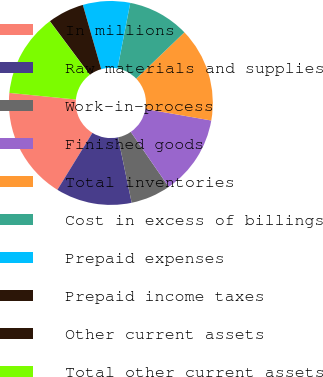<chart> <loc_0><loc_0><loc_500><loc_500><pie_chart><fcel>In millions<fcel>Raw materials and supplies<fcel>Work-in-process<fcel>Finished goods<fcel>Total inventories<fcel>Cost in excess of billings<fcel>Prepaid expenses<fcel>Prepaid income taxes<fcel>Other current assets<fcel>Total other current assets<nl><fcel>17.79%<fcel>12.06%<fcel>6.33%<fcel>12.64%<fcel>14.93%<fcel>9.77%<fcel>7.48%<fcel>5.76%<fcel>0.03%<fcel>13.21%<nl></chart> 